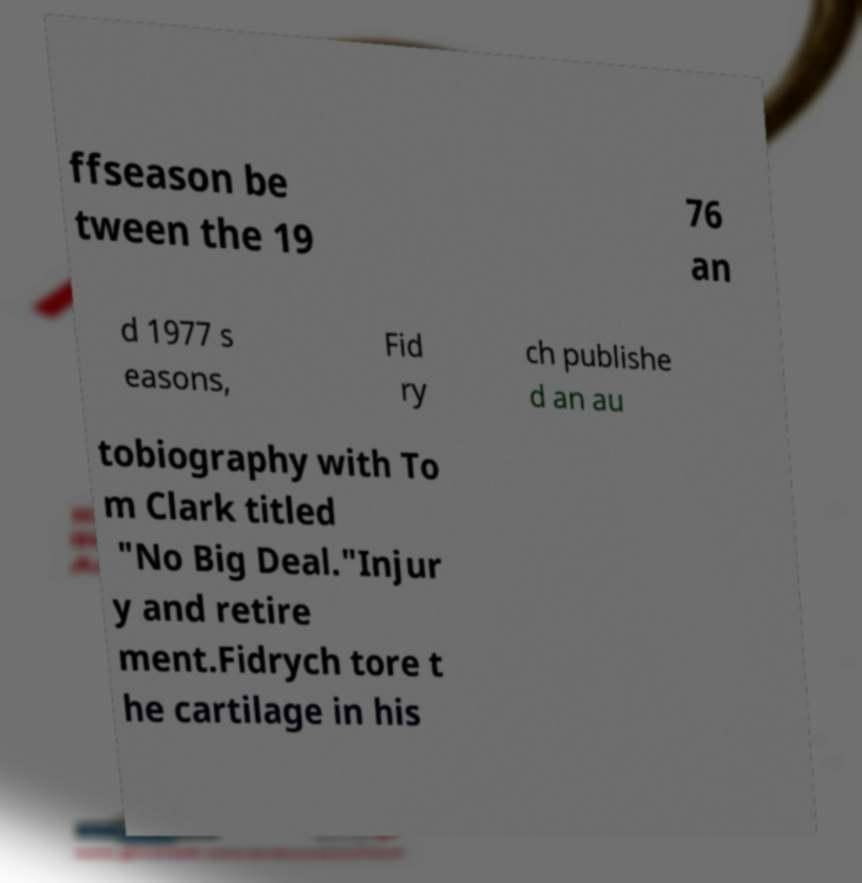Could you assist in decoding the text presented in this image and type it out clearly? ffseason be tween the 19 76 an d 1977 s easons, Fid ry ch publishe d an au tobiography with To m Clark titled "No Big Deal."Injur y and retire ment.Fidrych tore t he cartilage in his 